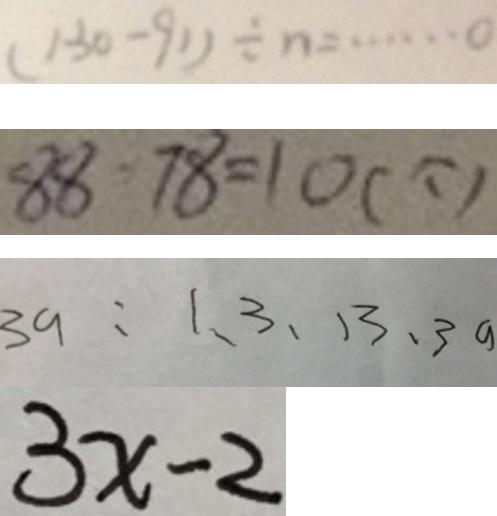Convert formula to latex. <formula><loc_0><loc_0><loc_500><loc_500>( 1 3 1 - 9 1 ) \div n = \cdots 0 
 8 8 - 7 8 = 1 0 ( 个 ) 
 3 a = 1 、 3 、 1 3 、 3 a 
 3 x - 2</formula> 